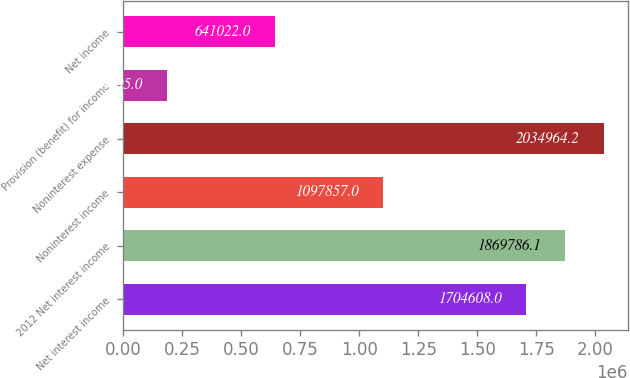<chart> <loc_0><loc_0><loc_500><loc_500><bar_chart><fcel>Net interest income<fcel>2012 Net interest income<fcel>Noninterest income<fcel>Noninterest expense<fcel>Provision (benefit) for income<fcel>Net income<nl><fcel>1.70461e+06<fcel>1.86979e+06<fcel>1.09786e+06<fcel>2.03496e+06<fcel>184095<fcel>641022<nl></chart> 